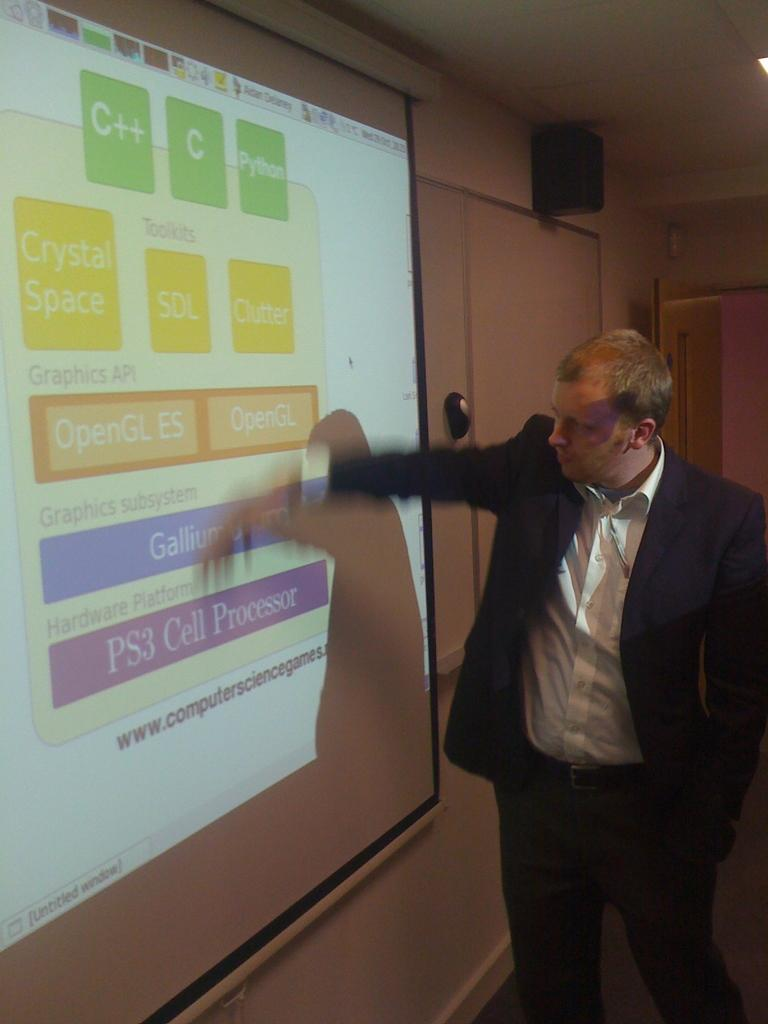<image>
Present a compact description of the photo's key features. A man wearing a sportcoat is giving a presentation about PS3 Cell processors. 